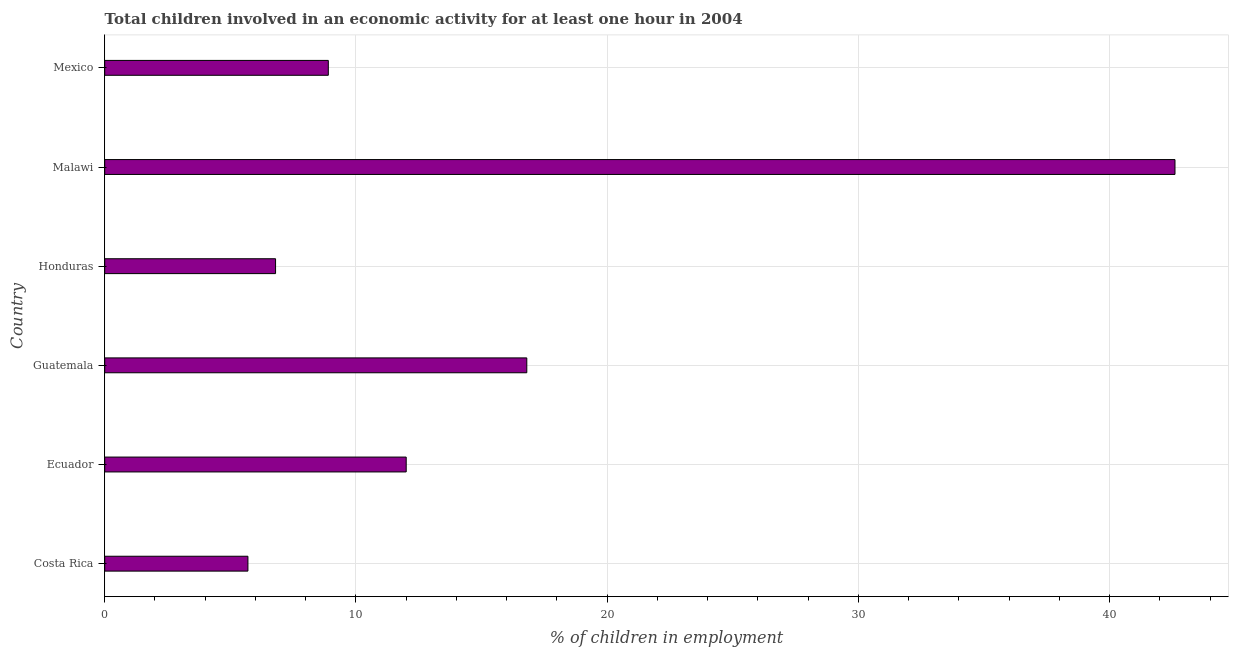Does the graph contain any zero values?
Your response must be concise. No. Does the graph contain grids?
Your answer should be very brief. Yes. What is the title of the graph?
Make the answer very short. Total children involved in an economic activity for at least one hour in 2004. What is the label or title of the X-axis?
Offer a terse response. % of children in employment. What is the label or title of the Y-axis?
Offer a very short reply. Country. What is the percentage of children in employment in Guatemala?
Provide a succinct answer. 16.8. Across all countries, what is the maximum percentage of children in employment?
Your answer should be very brief. 42.6. In which country was the percentage of children in employment maximum?
Make the answer very short. Malawi. In which country was the percentage of children in employment minimum?
Keep it short and to the point. Costa Rica. What is the sum of the percentage of children in employment?
Your answer should be compact. 92.8. What is the difference between the percentage of children in employment in Costa Rica and Malawi?
Make the answer very short. -36.9. What is the average percentage of children in employment per country?
Keep it short and to the point. 15.47. What is the median percentage of children in employment?
Offer a terse response. 10.45. In how many countries, is the percentage of children in employment greater than 40 %?
Give a very brief answer. 1. What is the ratio of the percentage of children in employment in Honduras to that in Mexico?
Make the answer very short. 0.76. Is the difference between the percentage of children in employment in Costa Rica and Honduras greater than the difference between any two countries?
Your response must be concise. No. What is the difference between the highest and the second highest percentage of children in employment?
Provide a short and direct response. 25.8. What is the difference between the highest and the lowest percentage of children in employment?
Your answer should be very brief. 36.9. In how many countries, is the percentage of children in employment greater than the average percentage of children in employment taken over all countries?
Your answer should be very brief. 2. How many bars are there?
Your response must be concise. 6. How many countries are there in the graph?
Offer a very short reply. 6. What is the difference between two consecutive major ticks on the X-axis?
Provide a succinct answer. 10. What is the % of children in employment of Costa Rica?
Provide a short and direct response. 5.7. What is the % of children in employment of Guatemala?
Ensure brevity in your answer.  16.8. What is the % of children in employment in Malawi?
Ensure brevity in your answer.  42.6. What is the difference between the % of children in employment in Costa Rica and Guatemala?
Offer a terse response. -11.1. What is the difference between the % of children in employment in Costa Rica and Malawi?
Ensure brevity in your answer.  -36.9. What is the difference between the % of children in employment in Costa Rica and Mexico?
Provide a short and direct response. -3.2. What is the difference between the % of children in employment in Ecuador and Guatemala?
Make the answer very short. -4.8. What is the difference between the % of children in employment in Ecuador and Malawi?
Provide a short and direct response. -30.6. What is the difference between the % of children in employment in Guatemala and Honduras?
Your response must be concise. 10. What is the difference between the % of children in employment in Guatemala and Malawi?
Provide a short and direct response. -25.8. What is the difference between the % of children in employment in Guatemala and Mexico?
Provide a succinct answer. 7.9. What is the difference between the % of children in employment in Honduras and Malawi?
Keep it short and to the point. -35.8. What is the difference between the % of children in employment in Malawi and Mexico?
Make the answer very short. 33.7. What is the ratio of the % of children in employment in Costa Rica to that in Ecuador?
Your answer should be compact. 0.47. What is the ratio of the % of children in employment in Costa Rica to that in Guatemala?
Give a very brief answer. 0.34. What is the ratio of the % of children in employment in Costa Rica to that in Honduras?
Your response must be concise. 0.84. What is the ratio of the % of children in employment in Costa Rica to that in Malawi?
Offer a very short reply. 0.13. What is the ratio of the % of children in employment in Costa Rica to that in Mexico?
Make the answer very short. 0.64. What is the ratio of the % of children in employment in Ecuador to that in Guatemala?
Offer a terse response. 0.71. What is the ratio of the % of children in employment in Ecuador to that in Honduras?
Ensure brevity in your answer.  1.76. What is the ratio of the % of children in employment in Ecuador to that in Malawi?
Provide a succinct answer. 0.28. What is the ratio of the % of children in employment in Ecuador to that in Mexico?
Provide a short and direct response. 1.35. What is the ratio of the % of children in employment in Guatemala to that in Honduras?
Offer a terse response. 2.47. What is the ratio of the % of children in employment in Guatemala to that in Malawi?
Offer a very short reply. 0.39. What is the ratio of the % of children in employment in Guatemala to that in Mexico?
Provide a short and direct response. 1.89. What is the ratio of the % of children in employment in Honduras to that in Malawi?
Give a very brief answer. 0.16. What is the ratio of the % of children in employment in Honduras to that in Mexico?
Your answer should be compact. 0.76. What is the ratio of the % of children in employment in Malawi to that in Mexico?
Give a very brief answer. 4.79. 